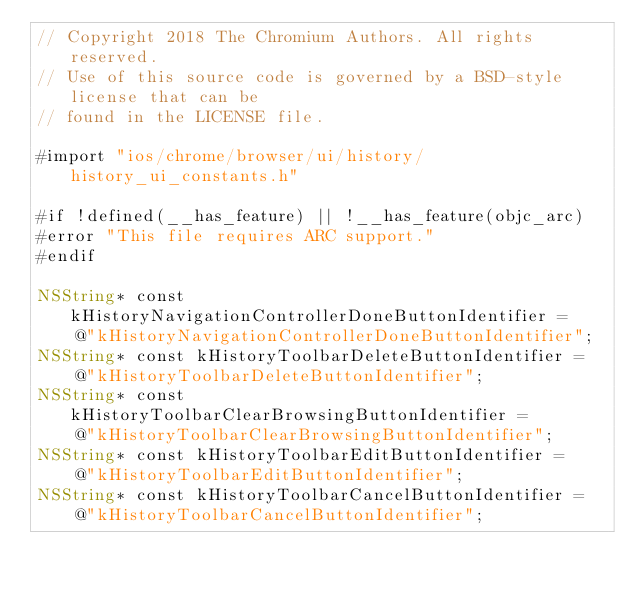<code> <loc_0><loc_0><loc_500><loc_500><_ObjectiveC_>// Copyright 2018 The Chromium Authors. All rights reserved.
// Use of this source code is governed by a BSD-style license that can be
// found in the LICENSE file.

#import "ios/chrome/browser/ui/history/history_ui_constants.h"

#if !defined(__has_feature) || !__has_feature(objc_arc)
#error "This file requires ARC support."
#endif

NSString* const kHistoryNavigationControllerDoneButtonIdentifier =
    @"kHistoryNavigationControllerDoneButtonIdentifier";
NSString* const kHistoryToolbarDeleteButtonIdentifier =
    @"kHistoryToolbarDeleteButtonIdentifier";
NSString* const kHistoryToolbarClearBrowsingButtonIdentifier =
    @"kHistoryToolbarClearBrowsingButtonIdentifier";
NSString* const kHistoryToolbarEditButtonIdentifier =
    @"kHistoryToolbarEditButtonIdentifier";
NSString* const kHistoryToolbarCancelButtonIdentifier =
    @"kHistoryToolbarCancelButtonIdentifier";
</code> 